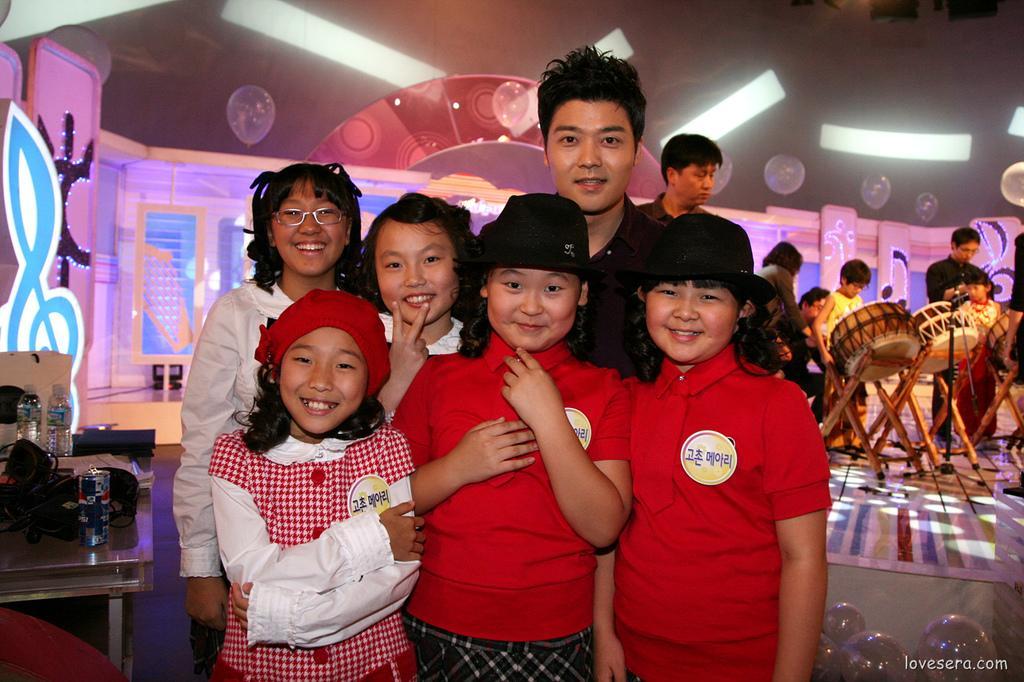How would you summarize this image in a sentence or two? In this image I can see number of people are standing, I can also see smile on their faces. In the background on this table I can see a can and few bottles. Here I can see few musical instruments. 